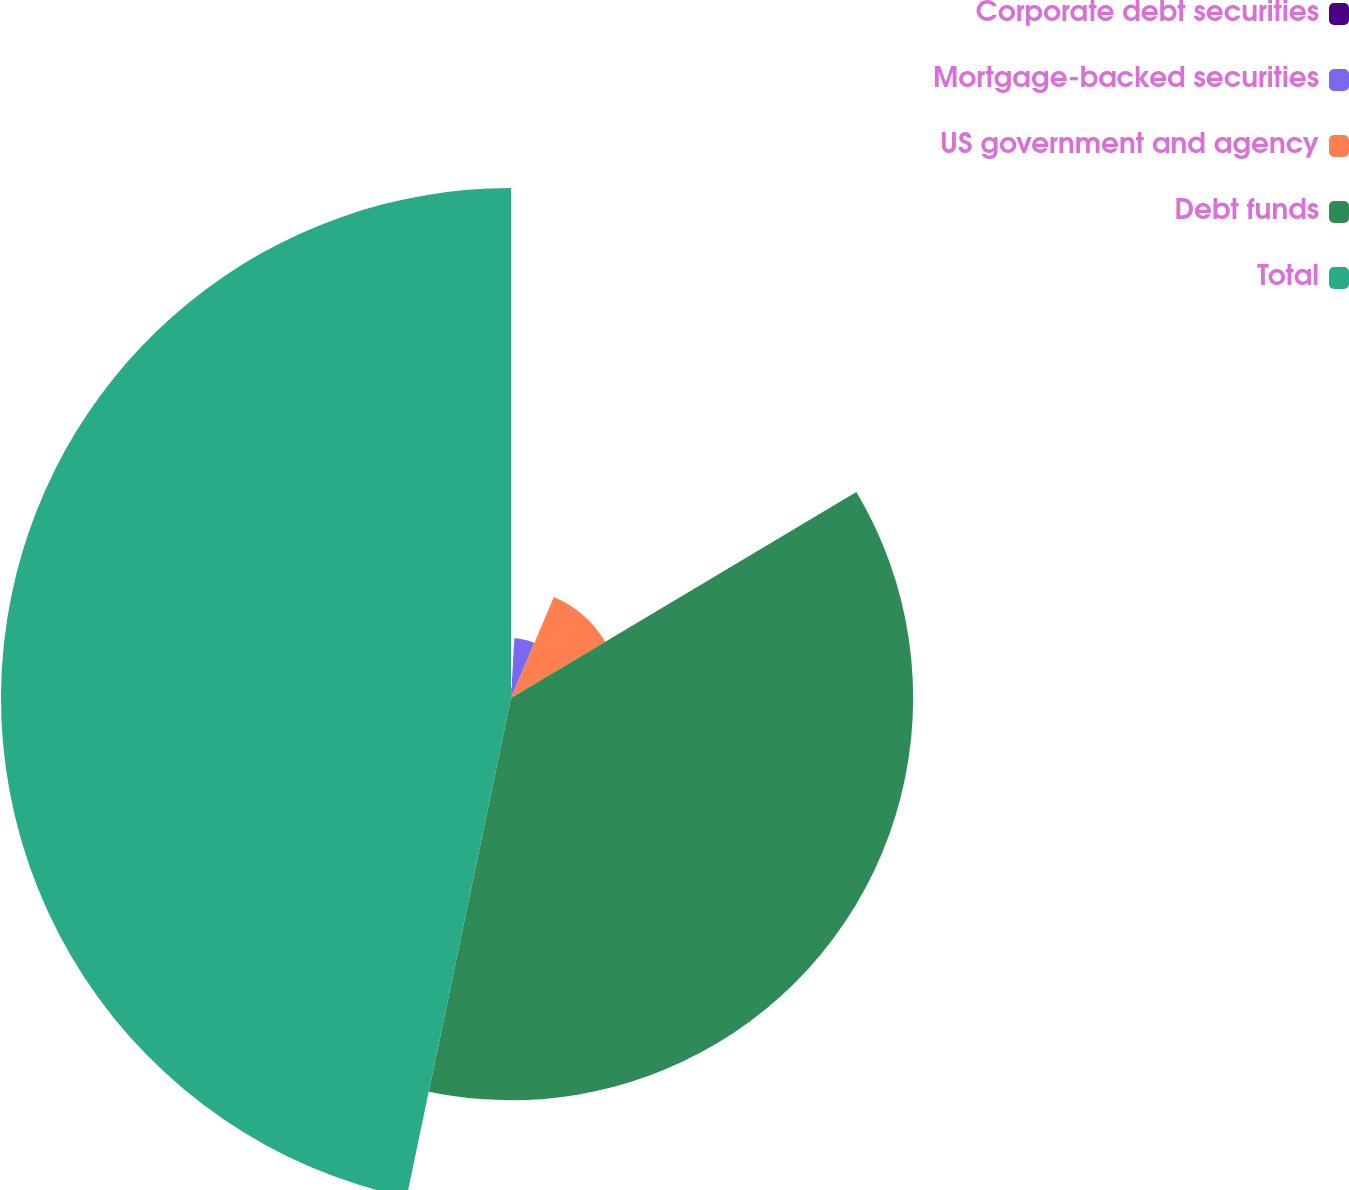<chart> <loc_0><loc_0><loc_500><loc_500><pie_chart><fcel>Corporate debt securities<fcel>Mortgage-backed securities<fcel>US government and agency<fcel>Debt funds<fcel>Total<nl><fcel>0.9%<fcel>5.48%<fcel>10.06%<fcel>36.84%<fcel>46.72%<nl></chart> 